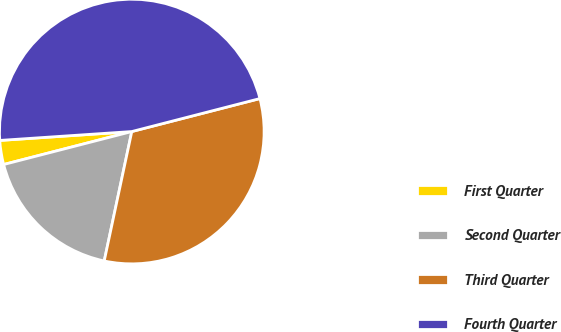Convert chart. <chart><loc_0><loc_0><loc_500><loc_500><pie_chart><fcel>First Quarter<fcel>Second Quarter<fcel>Third Quarter<fcel>Fourth Quarter<nl><fcel>2.94%<fcel>17.65%<fcel>32.35%<fcel>47.06%<nl></chart> 